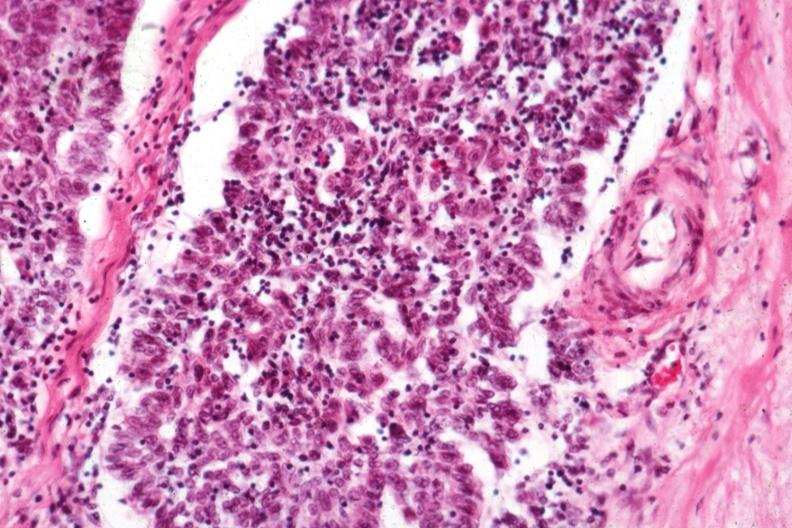what is present?
Answer the question using a single word or phrase. Hematologic 